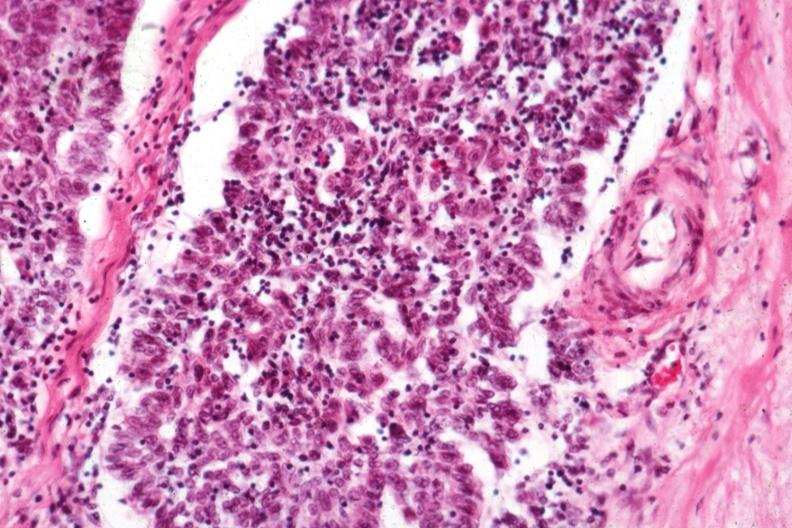what is present?
Answer the question using a single word or phrase. Hematologic 